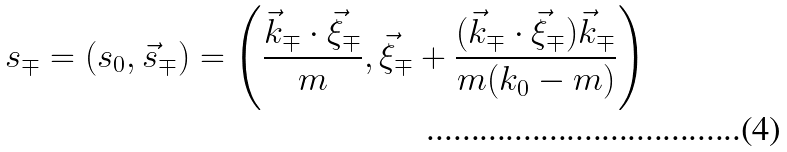Convert formula to latex. <formula><loc_0><loc_0><loc_500><loc_500>s _ { \mp } = ( s _ { 0 } , \vec { s } _ { \mp } ) = \left ( \frac { \vec { k } _ { \mp } \cdot \vec { \xi } _ { \mp } } m , \vec { \xi } _ { \mp } + \frac { ( \vec { k } _ { \mp } \cdot \vec { \xi } _ { \mp } ) \vec { k } _ { \mp } } { m ( k _ { 0 } - m ) } \right )</formula> 